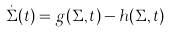Convert formula to latex. <formula><loc_0><loc_0><loc_500><loc_500>\dot { \Sigma } ( t ) = g ( \Sigma , t ) - h ( \Sigma , t )</formula> 